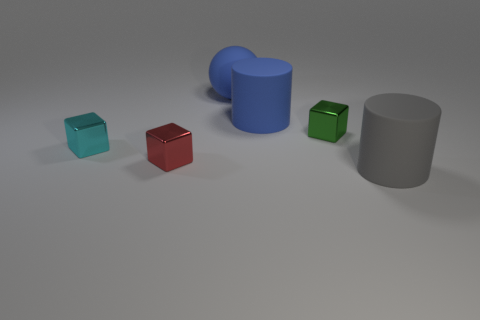Add 2 big blue shiny blocks. How many objects exist? 8 Subtract 2 cylinders. How many cylinders are left? 0 Subtract all balls. How many objects are left? 5 Subtract all red spheres. How many yellow blocks are left? 0 Subtract all green blocks. How many blocks are left? 2 Subtract all green balls. Subtract all cyan cylinders. How many balls are left? 1 Subtract all tiny yellow rubber cubes. Subtract all blue cylinders. How many objects are left? 5 Add 5 tiny red metallic objects. How many tiny red metallic objects are left? 6 Add 3 big rubber cylinders. How many big rubber cylinders exist? 5 Subtract 0 cyan cylinders. How many objects are left? 6 